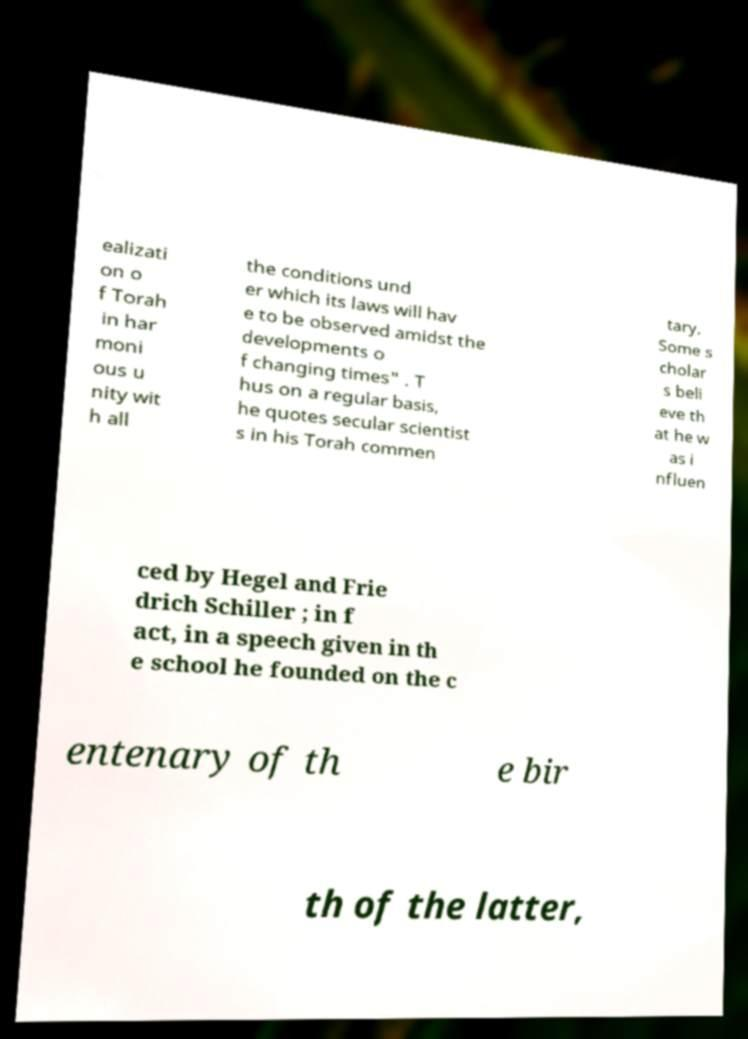Please read and relay the text visible in this image. What does it say? ealizati on o f Torah in har moni ous u nity wit h all the conditions und er which its laws will hav e to be observed amidst the developments o f changing times" . T hus on a regular basis, he quotes secular scientist s in his Torah commen tary. Some s cholar s beli eve th at he w as i nfluen ced by Hegel and Frie drich Schiller ; in f act, in a speech given in th e school he founded on the c entenary of th e bir th of the latter, 